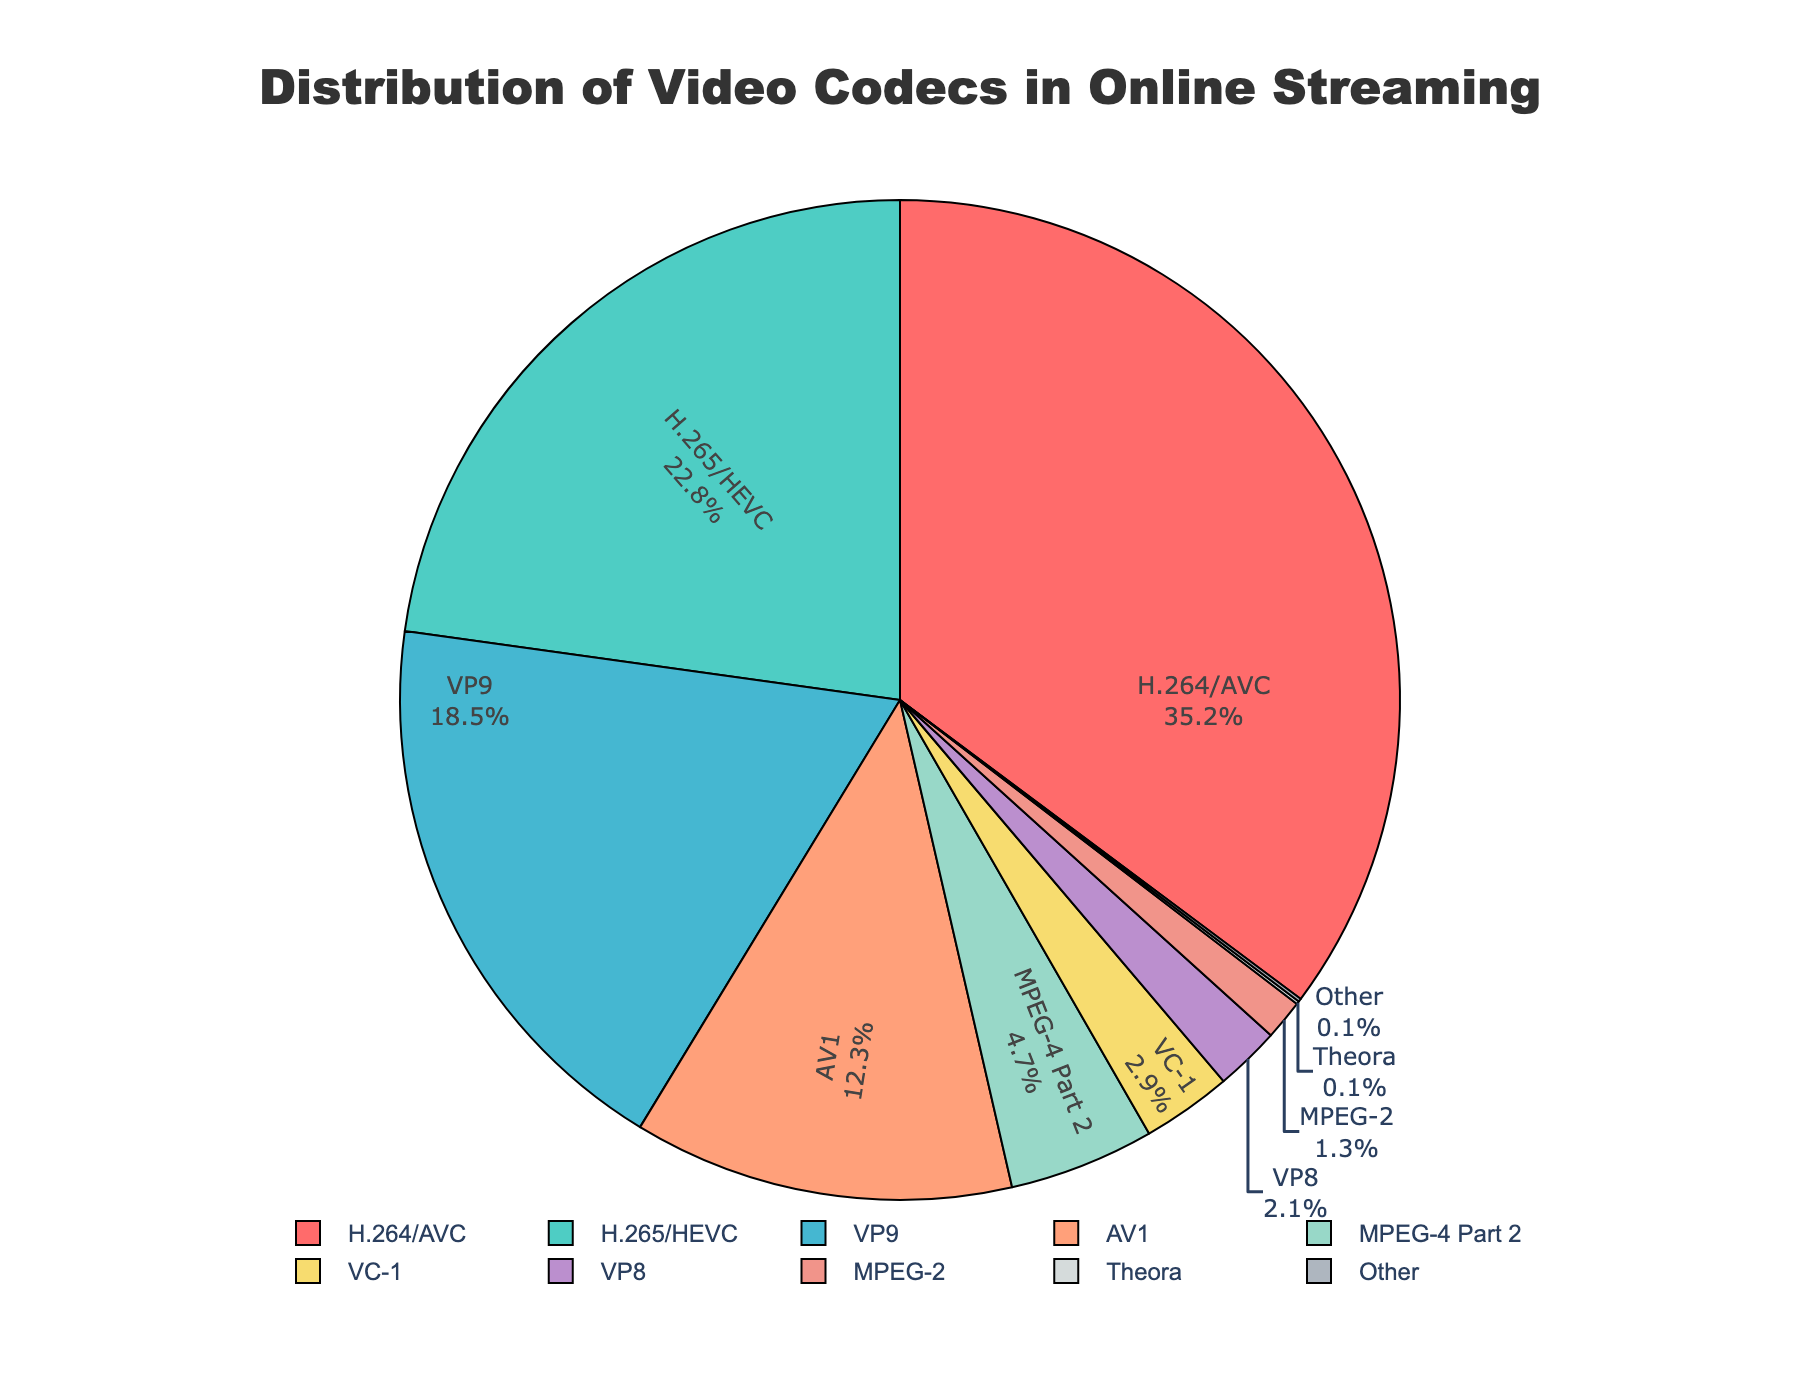Which codec has the largest market share? The pie chart shows various video codecs and their market shares. The slice labeled "H.264/AVC" is the largest.
Answer: H.264/AVC What's the combined market share of VP9 and AV1? Add the percentages of VP9 and AV1 from the pie chart. VP9 is 18.5%, and AV1 is 12.3%. So, 18.5 + 12.3 = 30.8%.
Answer: 30.8% How does the market share of H.265/HEVC compare to that of H.264/AVC? H.265/HEVC has a smaller slice than H.264/AVC in the pie chart. The exact percentages are 22.8% for H.265/HEVC and 35.2% for H.264/AVC.
Answer: H.265/HEVC is smaller Which codec is represented by the blue color? The pie chart uses colors to distinguish slices. According to the color palette described in the code, blue is likely associated with VP9.
Answer: VP9 What is the total market share of the codecs with less than 5% each? Identify the slices with less than 5% from the chart: MPEG-4 Part 2 (4.7%), VC-1 (2.9%), VP8 (2.1%), MPEG-2 (1.3%), Theora (0.1%), Other (0.1%). Add them: 4.7 + 2.9 + 2.1 + 1.3 + 0.1 + 0.1 = 11.2%.
Answer: 11.2% What is the percentage difference between H.264/AVC and H.265/HEVC? Subtract the percentage of H.265/HEVC from H.264/AVC. 35.2% (H.264/AVC) - 22.8% (H.265/HEVC) = 12.4%.
Answer: 12.4% If the chart were to focus only on codecs with more than 10% market share, which codecs would be included? Identify slices with more than 10%: H.264/AVC (35.2%), H.265/HEVC (22.8%), VP9 (18.5%), AV1 (12.3%).
Answer: H.264/AVC, H.265/HEVC, VP9, AV1 Which codec has the smallest market share and how much is it? The smallest slice in the pie chart is labeled with "Other" and represents 0.1%.
Answer: Other, 0.1% 